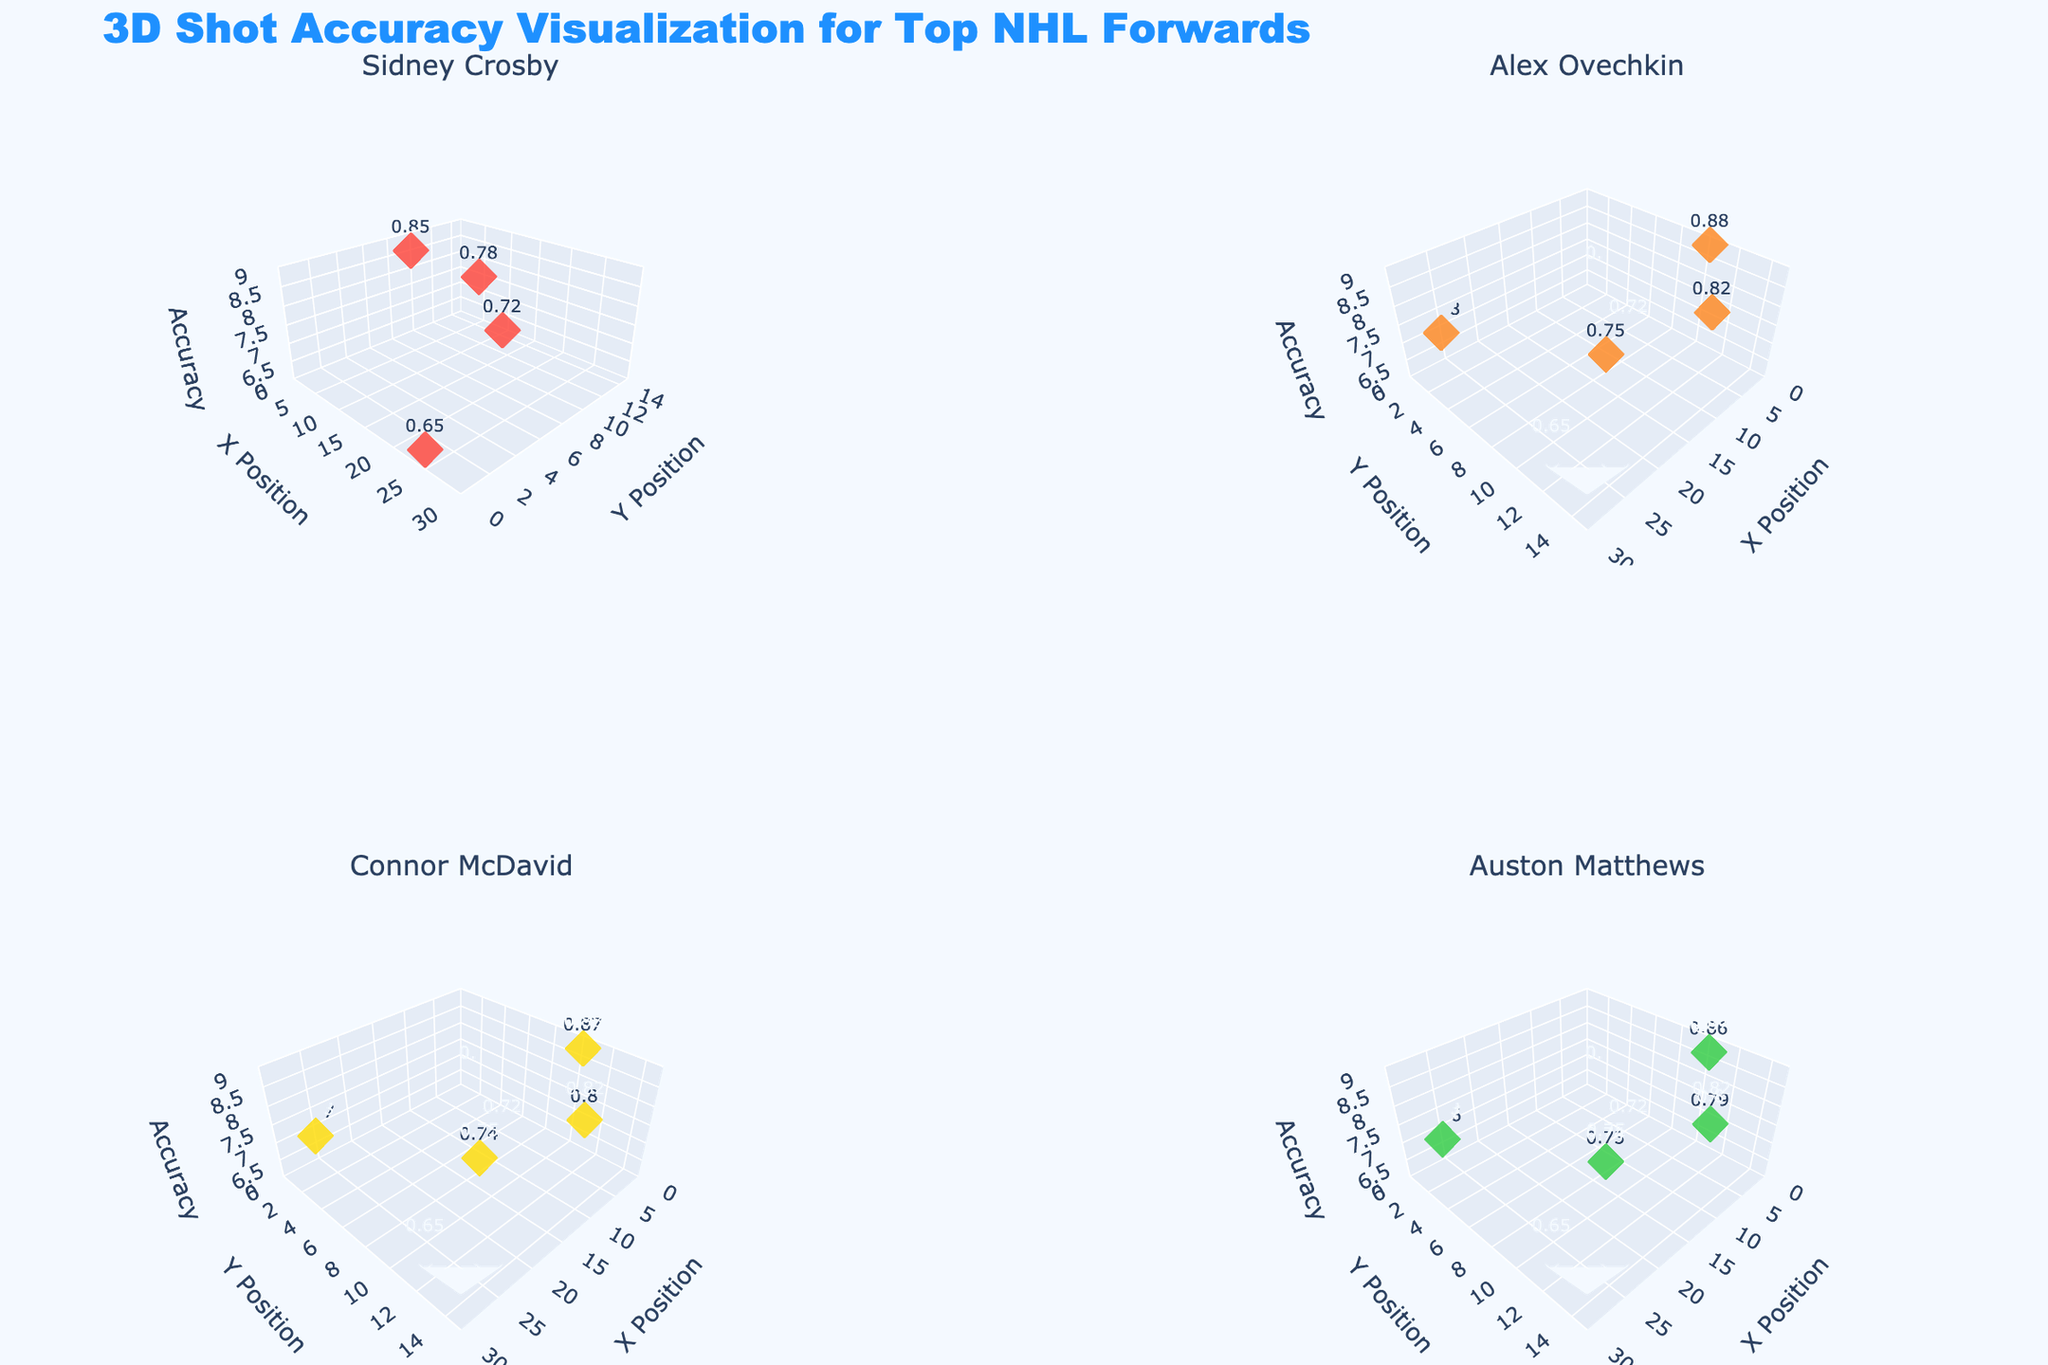What is the overall title of the figure? The title is displayed at the top of the figure, and it reads, "3D Shot Accuracy Visualization for Top NHL Forwards".
Answer: 3D Shot Accuracy Visualization for Top NHL Forwards How many forwards' data are visualized in the subplots? Each subplot represents one forward, and there are four subplots, each titled with a player's name.
Answer: 4 Which player has the highest shot accuracy from a 10-degree angle? By looking at the z-coordinates (shot accuracy) corresponding to the trial with a 10-degree angle across all subplots, Alex Ovechkin has the highest at 0.88.
Answer: Alex Ovechkin What are the axis titles for each subplot? Each subplot has x-axis labeled 'X Position', y-axis labeled 'Y Position', and z-axis labeled 'Accuracy'.
Answer: X Position, Y Position, Accuracy Compared to Connor McDavid, how much higher is Sidney Crosby's accuracy from 90 degrees? Sidney Crosby's accuracy from 90 degrees is 6.5 and Connor McDavid's is 6.7, so Crosby's accuracy is 0.2 lower.
Answer: 0.2 lower In terms of z-axis accuracy, which player displayed the least accuracy variance? Checking the range of z-coordinates (accuracy values) of each player: Sidney Crosby's range is 0.65 to 0.85 with a variance of 0.20.
Answer: Sidney Crosby How does the shot accuracy of Auston Matthews compare to Sidney Crosby at a distance of 15? Auston Matthews' accuracy at 15 (30 degrees angle) is 7.9, while Sidney Crosby's is 7.8, so Matthews' accuracy is 0.1 higher.
Answer: 0.1 higher Which player's shot accuracy data points form the steepest gradient along the z-axis? Looking at the changes in accuracy (z-axis values) across different distances and angles, Alex Ovechkin shows the most drastic changes.
Answer: Alex Ovechkin 